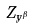<formula> <loc_0><loc_0><loc_500><loc_500>Z _ { y ^ { \beta } }</formula> 